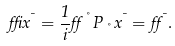<formula> <loc_0><loc_0><loc_500><loc_500>\delta x ^ { \mu } = \frac { 1 } { i } \alpha ^ { \nu } P _ { \nu } x ^ { \mu } = \alpha ^ { \mu } .</formula> 